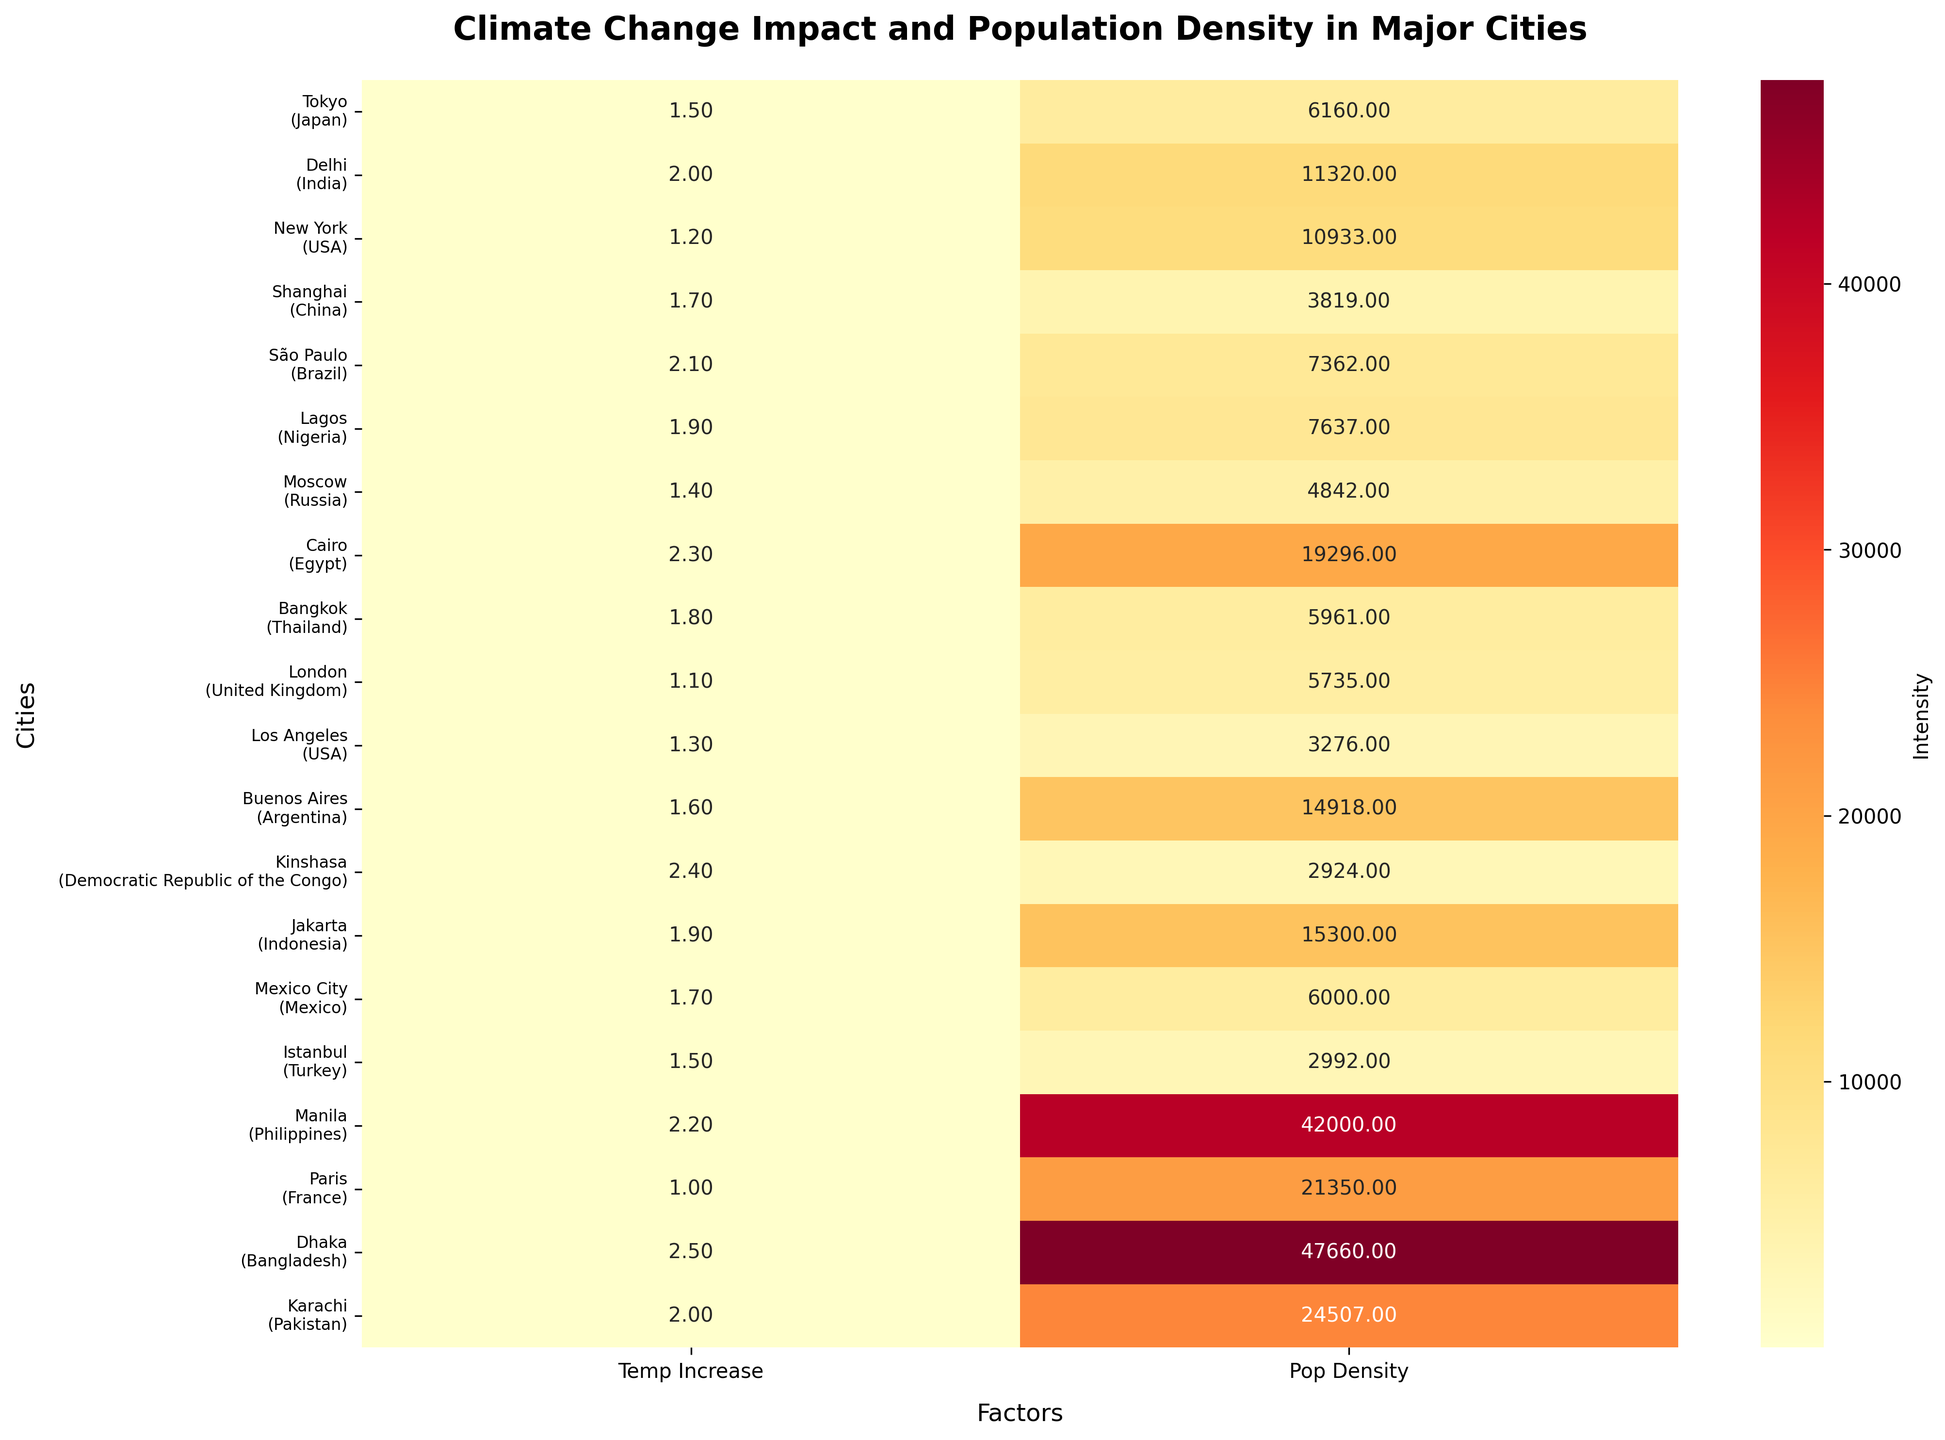Which city has the highest population density? The heatmap shows that Dhaka has the darkest color in the population density column, indicating it has the highest value.
Answer: Dhaka Which city has the largest temperature increase? By comparing the intensity of colors in the temperature increase column, Dhaka shows the darkest color, indicating it has the highest temperature increase.
Answer: Dhaka What is the title of the heatmap? The title is displayed at the top of the heatmap.
Answer: Climate Change Impact and Population Density in Major Cities Which city in Africa has the highest temperature increase? By looking down the list for cities in Africa, Kinshasa's temperature increase column has the darkest color among the African cities indicating the highest temperature increase.
Answer: Kinshasa Which region shows the most consistent (least varied) temperature increases among its cities? By comparing the shades of the temperature increase columns across regions, Asia shows relatively consistent colors without wild variations.
Answer: Asia What is the average population density of the cities shown on the heatmap? Sum the population densities of all cities and divide by the number of cities: (6160 + 11320 + 10933 + 3819 + 7362 + 7637 + 4842 + 19296 + 5961 + 5735 + 3276 + 14918 + 2924 + 15300 + 6000 + 2992 + 42000 + 21350 + 47660) / 19 = 13,086 people/km^2.
Answer: 13,086 Compare the temperature increases of New York and Los Angeles. Which one has a higher increase? By looking at the temperature increase columns for New York and Los Angeles, New York's value of 1.2°C is greater than Los Angeles's 1.3°C.
Answer: New York Which European city has the lowest temperature increase? The temperature increase colors in Europe show Paris as the lightest, indicating the lowest value.
Answer: Paris Identify the region with the highest aggregated temperature increase among its cities. Summing the temperature increases for each region and comparing, Asia has the highest total.
Answer: Asia What is the median temperature increase across all cities? Sorting the temperature increases: [1.0, 1.1, 1.2, 1.3, 1.4, 1.5, 1.5, 1.6, 1.7, 1.7, 1.8, 1.9, 1.9, 2.0, 2.0, 2.1, 2.2, 2.3, 2.4, 2.5]. The middle value or median is the average of the 10th and 11th values: (1.8 + 1.7)/2= 1.75°C.
Answer: 1.75°C 